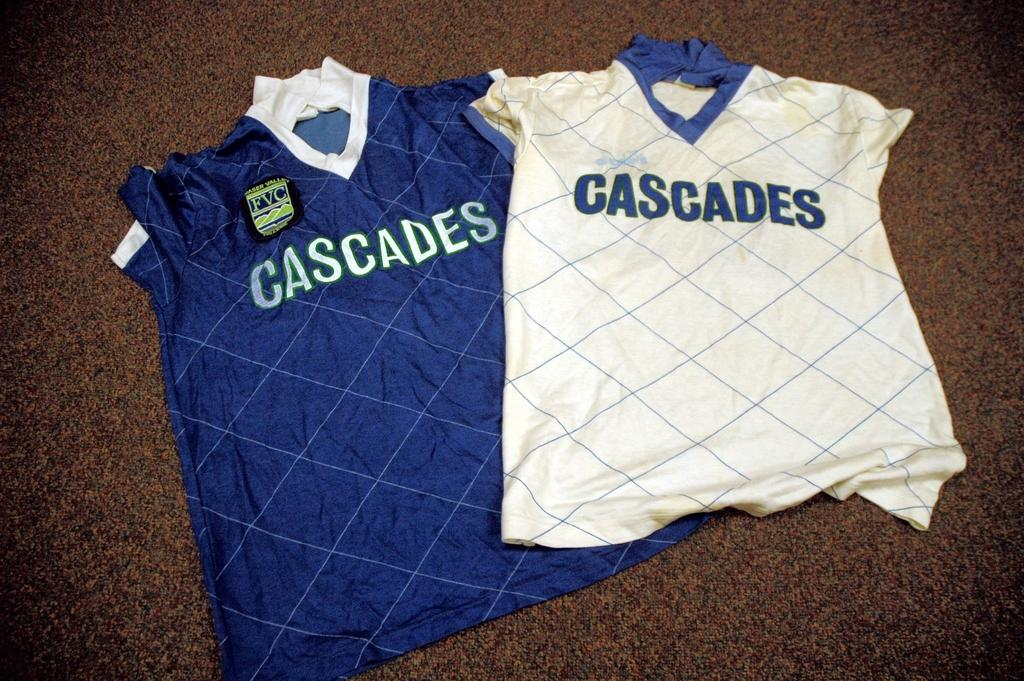<image>
Give a short and clear explanation of the subsequent image. a shirt that says the word cascades on it 